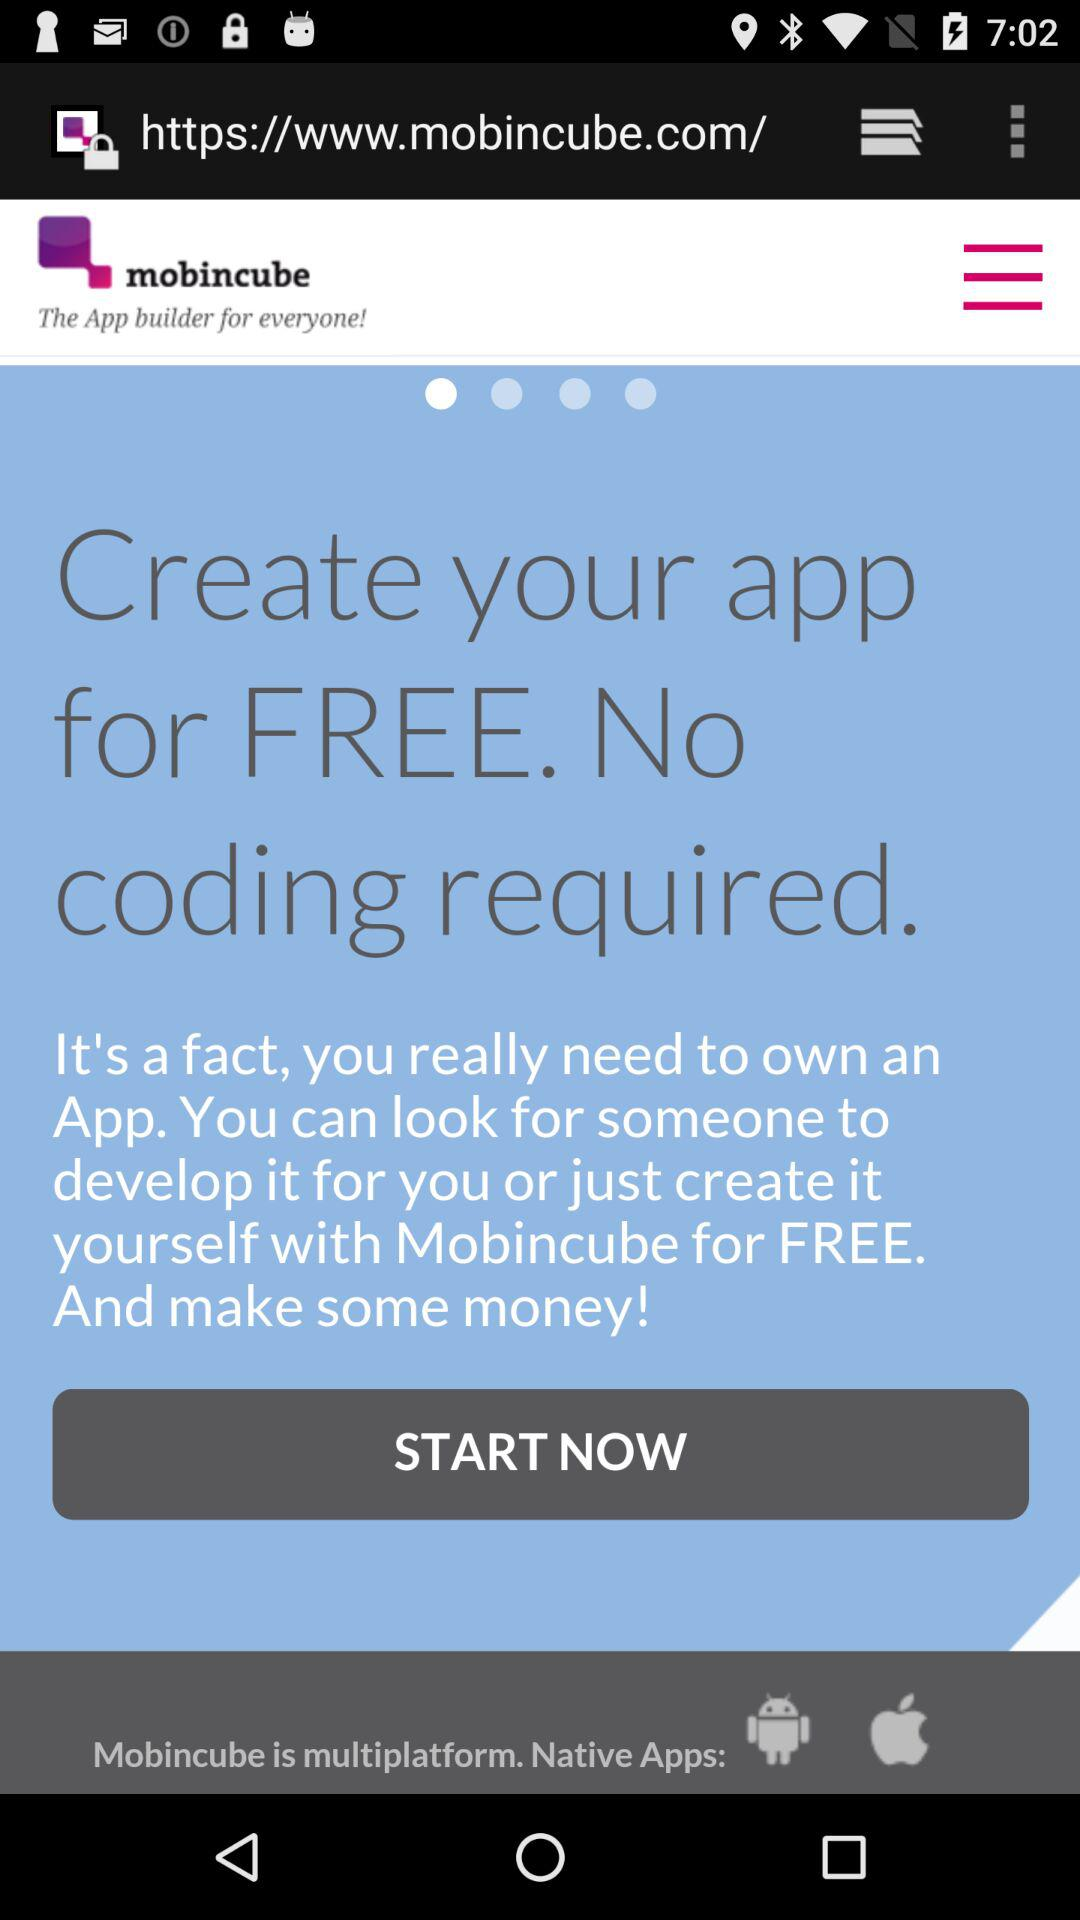What is the name of the application? The name of the application is "mobincube". 